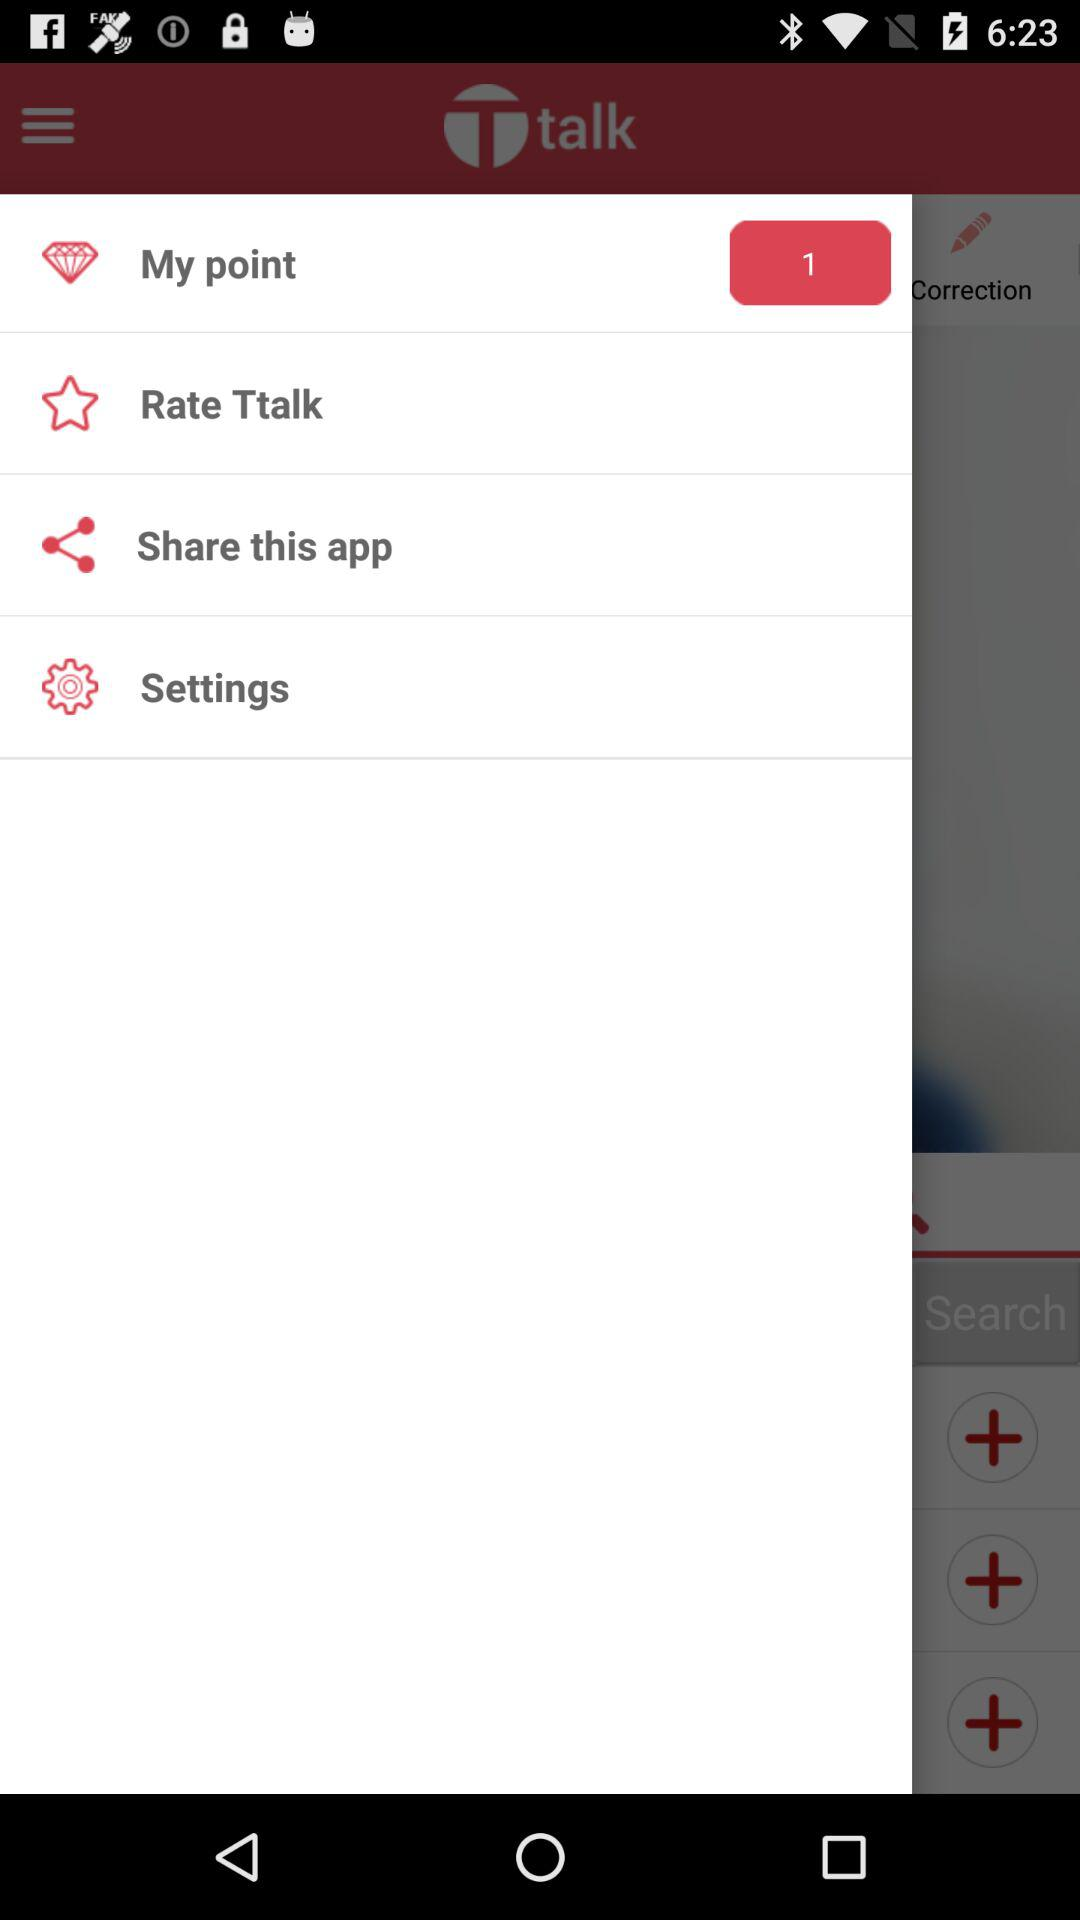How many points do I have? You have 1 point. 